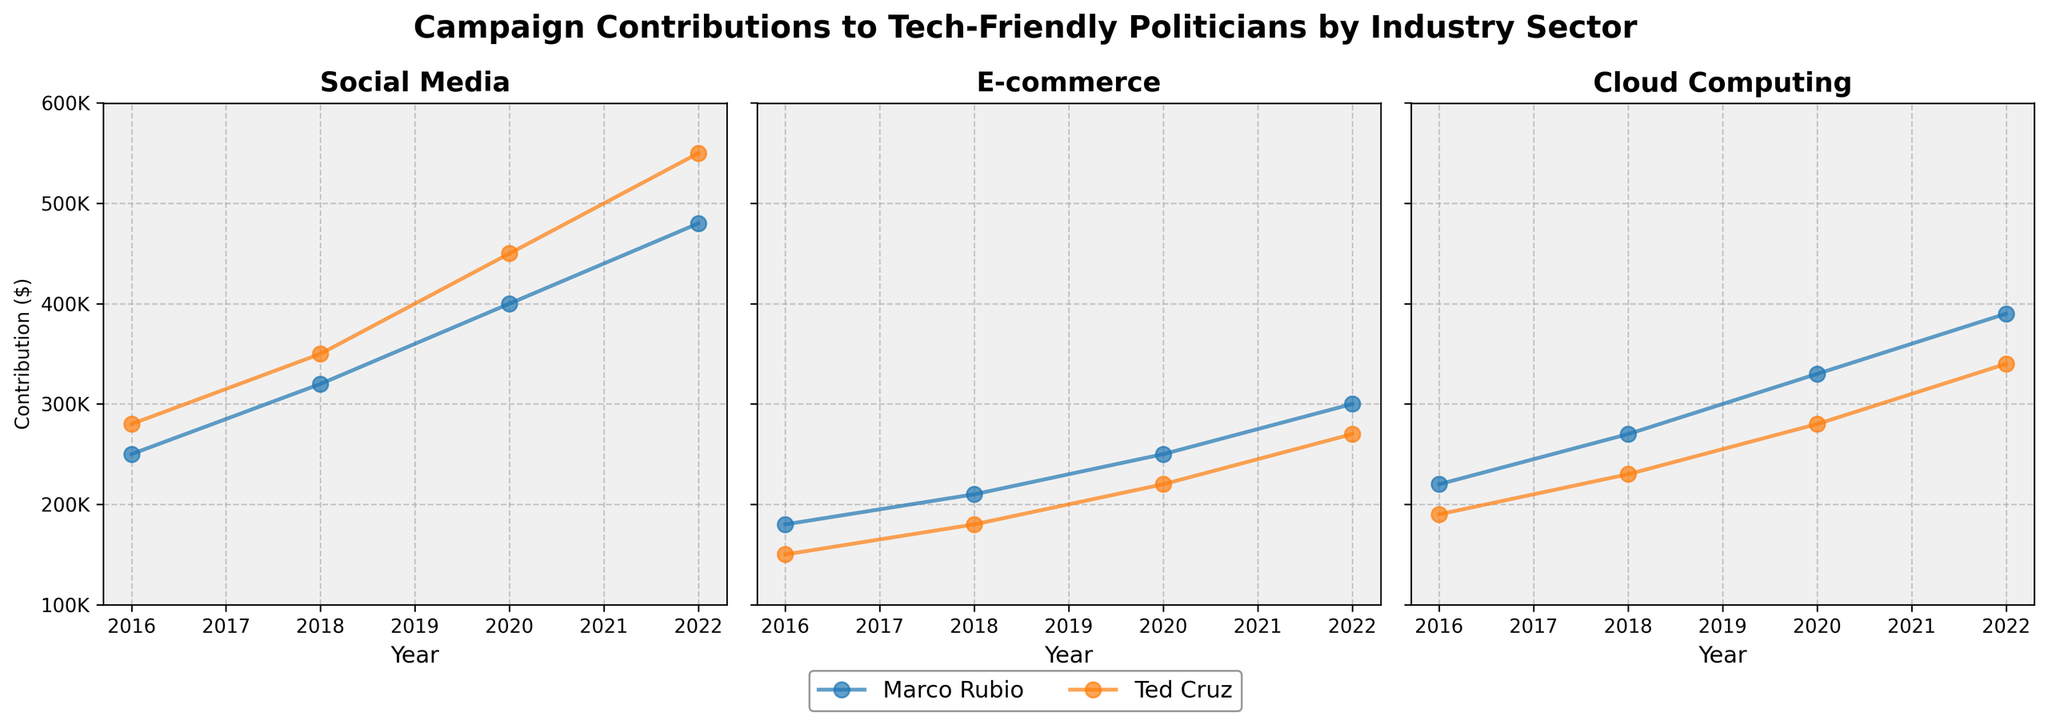What is the title of the figure? The title is usually found at the top of the figure. In this case, it says "Campaign Contributions to Tech-Friendly Politicians by Industry Sector".
Answer: Campaign Contributions to Tech-Friendly Politicians by Industry Sector What are the three sectors represented in the subplots? The sectors are labeled at the top of each subplot. They are Social Media, E-commerce, and Cloud Computing.
Answer: Social Media, E-commerce, Cloud Computing Who received more contributions in the Social Media sector in 2016, Marco Rubio or Ted Cruz? By examining the 2016 data points in the Social Media subplot, Ted Cruz received $280,000 while Marco Rubio received $250,000.
Answer: Ted Cruz Which sector saw the highest contribution to Marco Rubio in 2022? By looking at Marco Rubio's data points across all three subplots for the year 2022, the contributions are $480,000 (Social Media), $300,000 (E-commerce), and $390,000 (Cloud Computing). The highest is $480,000 in Social Media.
Answer: Social Media How much did total contributions to Ted Cruz in the E-commerce sector increase from 2016 to 2022? In the E-commerce subplot, Ted Cruz received $150,000 in 2016 and $270,000 in 2022. The difference is $270,000 - $150,000 = $120,000.
Answer: $120,000 Which tech sector showed the most consistent increase in contributions to Marco Rubio over the years? By examining Marco Rubio's data across all three subplots, it is clear that contributions in the Social Media sector increase steadily from $250,000 (2016) to $480,000 (2022) without any declines.
Answer: Social Media In which year did Ted Cruz receive the highest contributions in the Cloud Computing sector? By looking at the Cloud Computing subplot and identifying Ted Cruz’s data points: $190,000 (2016), $230,000 (2018), $280,000 (2020), and $340,000 (2022). The highest is $340,000 in 2022.
Answer: 2022 What was the combined total contribution to Marco Rubio across all sectors in 2018? Sum Marco Rubio's contributions in 2018 from all three subplots: $320,000 (Social Media) + $210,000 (E-commerce) + $270,000 (Cloud Computing) = $800,000.
Answer: $800,000 Compare the trends in contributions received by Marco Rubio and Ted Cruz in the E-commerce sector. In the E-commerce sector subplot, both Rubio and Cruz show increasing trends. Marco Rubio's contributions went from $180,000 (2016) to $300,000 (2022). Ted Cruz's contributions started at $150,000 (2016) and increased to $270,000 (2022). However, Rubio consistently received higher contributions in every year compared to Cruz.
Answer: Both increasing, Rubio consistently higher 